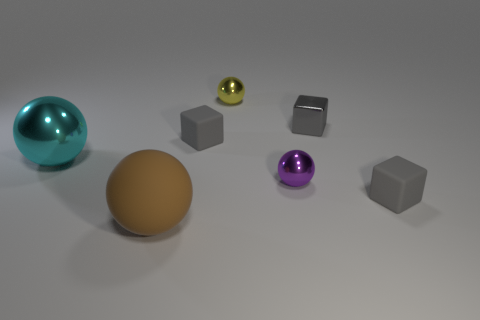There is a small purple thing that is the same shape as the large metal object; what is its material?
Make the answer very short. Metal. What number of tiny green rubber blocks are there?
Offer a terse response. 0. What is the shape of the gray object that is to the left of the tiny purple object?
Provide a short and direct response. Cube. What is the color of the small rubber block that is right of the small matte block behind the tiny gray object to the right of the small gray metallic thing?
Offer a very short reply. Gray. What shape is the small purple object that is the same material as the cyan object?
Your answer should be very brief. Sphere. Is the number of large red cylinders less than the number of rubber cubes?
Give a very brief answer. Yes. Does the tiny yellow object have the same material as the big brown ball?
Make the answer very short. No. How many other things are there of the same color as the matte sphere?
Your response must be concise. 0. Is the number of spheres greater than the number of large brown things?
Make the answer very short. Yes. Is the size of the yellow metallic ball the same as the matte thing right of the small yellow object?
Keep it short and to the point. Yes. 